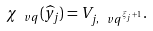<formula> <loc_0><loc_0><loc_500><loc_500>\chi _ { \ v q } ( \widehat { y } _ { j } ) = V _ { j , \ v q ^ { \xi _ { j } + 1 } } .</formula> 